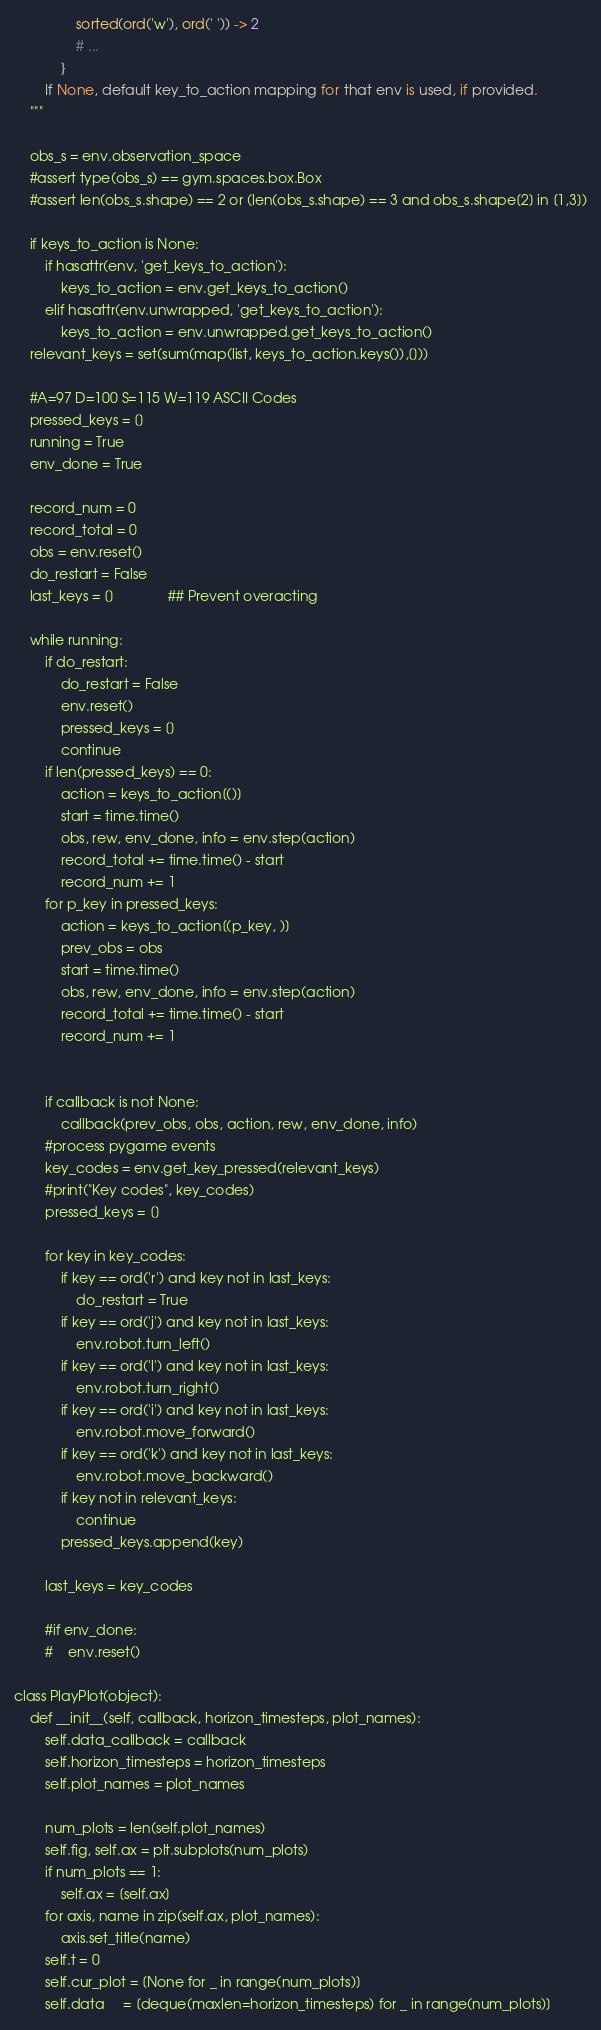Convert code to text. <code><loc_0><loc_0><loc_500><loc_500><_Python_>                sorted(ord('w'), ord(' ')) -> 2
                # ...
            }
        If None, default key_to_action mapping for that env is used, if provided.
    """

    obs_s = env.observation_space
    #assert type(obs_s) == gym.spaces.box.Box
    #assert len(obs_s.shape) == 2 or (len(obs_s.shape) == 3 and obs_s.shape[2] in [1,3])

    if keys_to_action is None:
        if hasattr(env, 'get_keys_to_action'):
            keys_to_action = env.get_keys_to_action()
        elif hasattr(env.unwrapped, 'get_keys_to_action'):
            keys_to_action = env.unwrapped.get_keys_to_action()
    relevant_keys = set(sum(map(list, keys_to_action.keys()),[]))

    #A=97 D=100 S=115 W=119 ASCII Codes
    pressed_keys = []
    running = True
    env_done = True

    record_num = 0
    record_total = 0
    obs = env.reset()
    do_restart = False
    last_keys = []              ## Prevent overacting

    while running:
        if do_restart:
            do_restart = False
            env.reset()
            pressed_keys = []
            continue
        if len(pressed_keys) == 0:
            action = keys_to_action[()]
            start = time.time()
            obs, rew, env_done, info = env.step(action)
            record_total += time.time() - start
            record_num += 1
        for p_key in pressed_keys:
            action = keys_to_action[(p_key, )]
            prev_obs = obs
            start = time.time()
            obs, rew, env_done, info = env.step(action)
            record_total += time.time() - start
            record_num += 1


        if callback is not None:
            callback(prev_obs, obs, action, rew, env_done, info)
        #process pygame events
        key_codes = env.get_key_pressed(relevant_keys)
        #print("Key codes", key_codes)
        pressed_keys = []

        for key in key_codes:
            if key == ord('r') and key not in last_keys:
                do_restart = True
            if key == ord('j') and key not in last_keys:
                env.robot.turn_left()
            if key == ord('l') and key not in last_keys:
                env.robot.turn_right()
            if key == ord('i') and key not in last_keys:
                env.robot.move_forward()
            if key == ord('k') and key not in last_keys:
                env.robot.move_backward()
            if key not in relevant_keys:
                continue
            pressed_keys.append(key) 
            
        last_keys = key_codes

        #if env_done:
        #    env.reset()

class PlayPlot(object):
    def __init__(self, callback, horizon_timesteps, plot_names):
        self.data_callback = callback
        self.horizon_timesteps = horizon_timesteps
        self.plot_names = plot_names

        num_plots = len(self.plot_names)
        self.fig, self.ax = plt.subplots(num_plots)
        if num_plots == 1:
            self.ax = [self.ax]
        for axis, name in zip(self.ax, plot_names):
            axis.set_title(name)
        self.t = 0
        self.cur_plot = [None for _ in range(num_plots)]
        self.data     = [deque(maxlen=horizon_timesteps) for _ in range(num_plots)]
</code> 